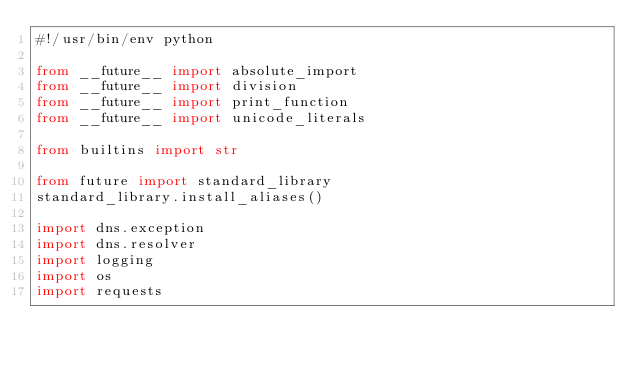Convert code to text. <code><loc_0><loc_0><loc_500><loc_500><_Python_>#!/usr/bin/env python

from __future__ import absolute_import
from __future__ import division
from __future__ import print_function
from __future__ import unicode_literals

from builtins import str

from future import standard_library
standard_library.install_aliases()

import dns.exception
import dns.resolver
import logging
import os
import requests</code> 